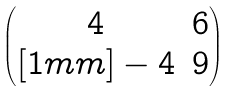Convert formula to latex. <formula><loc_0><loc_0><loc_500><loc_500>\begin{pmatrix} 4 & 6 \\ [ 1 m m ] - 4 & 9 \end{pmatrix}</formula> 